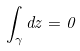<formula> <loc_0><loc_0><loc_500><loc_500>\int _ { \gamma } d z = 0</formula> 